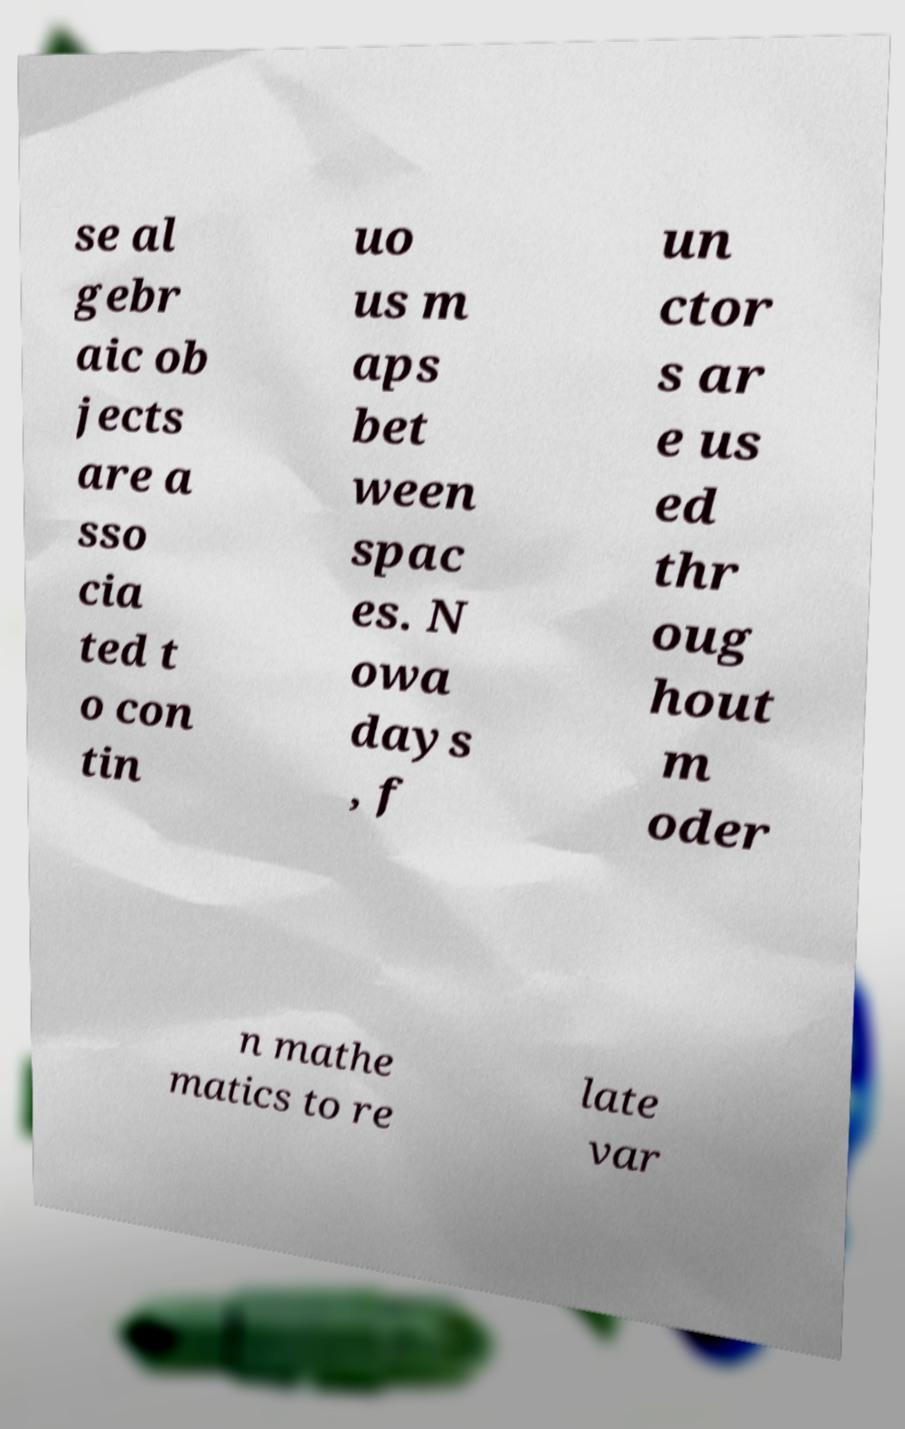There's text embedded in this image that I need extracted. Can you transcribe it verbatim? se al gebr aic ob jects are a sso cia ted t o con tin uo us m aps bet ween spac es. N owa days , f un ctor s ar e us ed thr oug hout m oder n mathe matics to re late var 